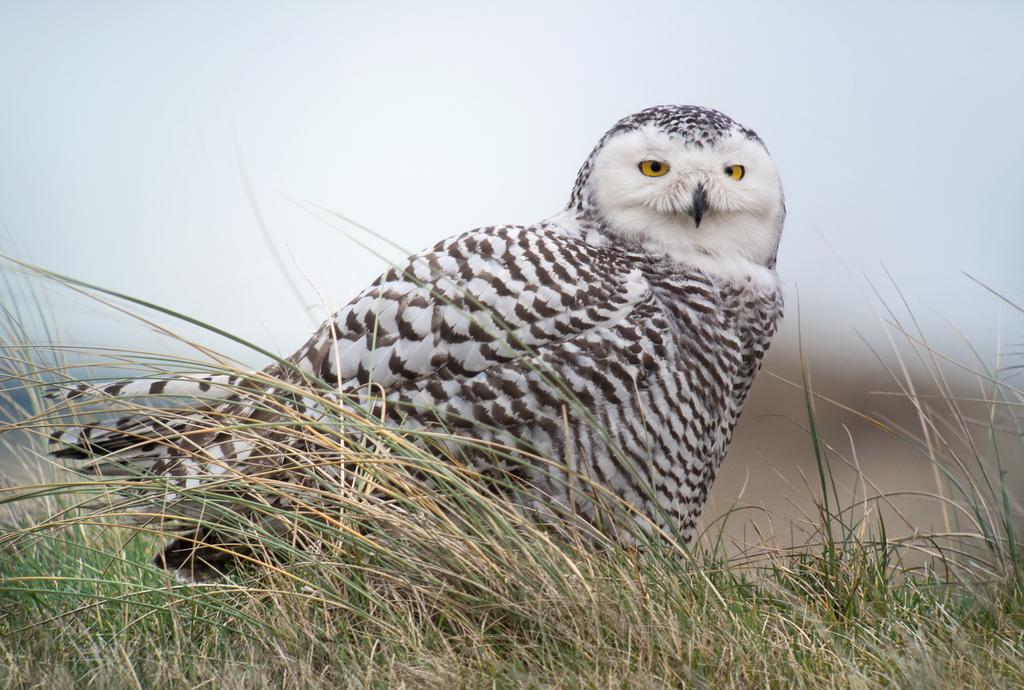What type of animal is in the image? There is an owl in the image. Where is the owl located? The owl is on the grass. What can be seen in the background of the image? The sky is visible in the background of the image. What type of blade is being used by the owl in the image? There is no blade present in the image; the owl is simply sitting on the grass. 